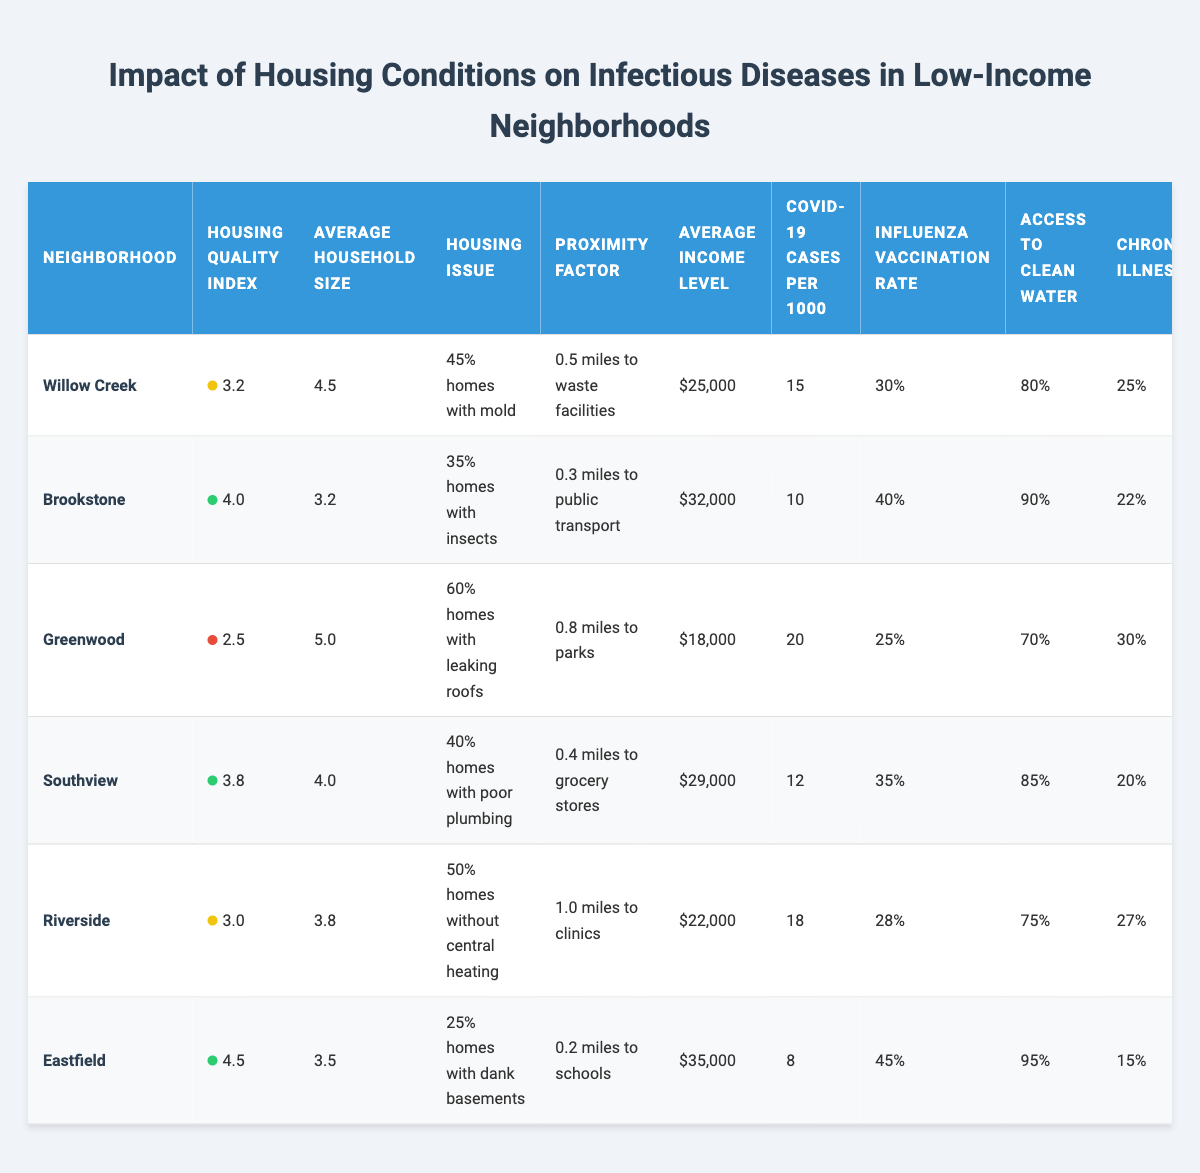What is the Housing Quality Index for Southview? Southview has a Housing Quality Index listed in the table directly. The value is 3.8.
Answer: 3.8 Which neighborhood has the highest COVID-19 cases per 1000 residents? By examining the COVID-19 cases per 1000 residents for each neighborhood, Greenwood has the highest value of 20 cases.
Answer: Greenwood What percentage of homes in Riverside lack central heating? The table states that 50% of homes in Riverside do not have central heating, which is directly retrievable from the information presented.
Answer: 50% What is the average income level of the neighborhoods listed? The average income levels for each neighborhood are (25000 + 32000 + 18000 + 29000 + 22000 + 35000) = 161000. With 6 neighborhoods, the average is 161000 / 6 = 26833.33, rounded to two decimal places it's 26833.33.
Answer: 26833.33 Is there a neighborhood with an influenza vaccination rate above 40%? Looking at the influenza vaccination rates, Brookstone (40%) is the only neighborhood reaching this threshold, but it does not exceed it. Therefore, no neighborhood exceeds 40%.
Answer: No Which neighborhood has the lowest access to clean water percentage? A direct comparison of access to clean water percentages shows that Greenwood has the lowest at 70%.
Answer: Greenwood How many hours per week do residents of Willow Creek spend in crowded spaces? The table indicates that residents of Willow Creek spend 15 hours per week in crowded spaces, which can be directly referenced from the data.
Answer: 15 hours What is the difference in average household size between Greenwood and Eastfield? The average household sizes are 5.0 for Greenwood and 3.5 for Eastfield. The difference is calculated as 5.0 - 3.5 = 1.5.
Answer: 1.5 Does every neighborhood have access to clean water over 75%? A quick review shows that Riverside has 75% access to clean water, while other neighborhoods have higher values, indicating Riverside is right at the threshold but does not exceed it. Therefore, not every neighborhood exceeds 75%.
Answer: No Which neighborhood has the highest percentage of homes with persistent pests? From the data, the highest percentage of homes with insects is in Brookstone at 35%, which can be determined straightforwardly by comparing the housing issues.
Answer: Brookstone 